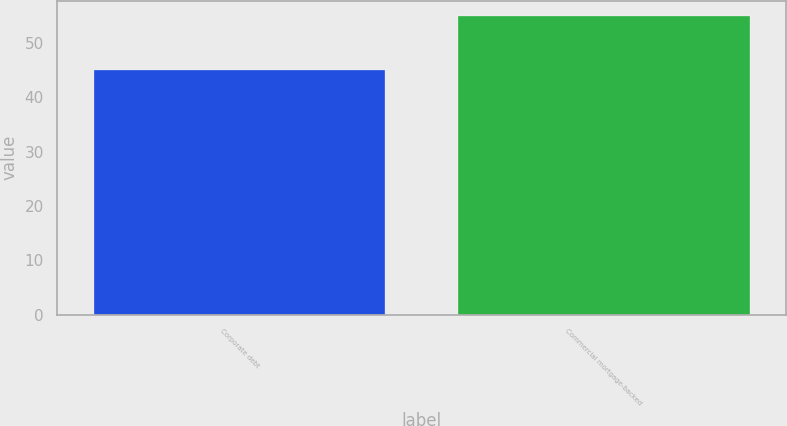Convert chart. <chart><loc_0><loc_0><loc_500><loc_500><bar_chart><fcel>Corporate debt<fcel>Commercial mortgage-backed<nl><fcel>45<fcel>55<nl></chart> 